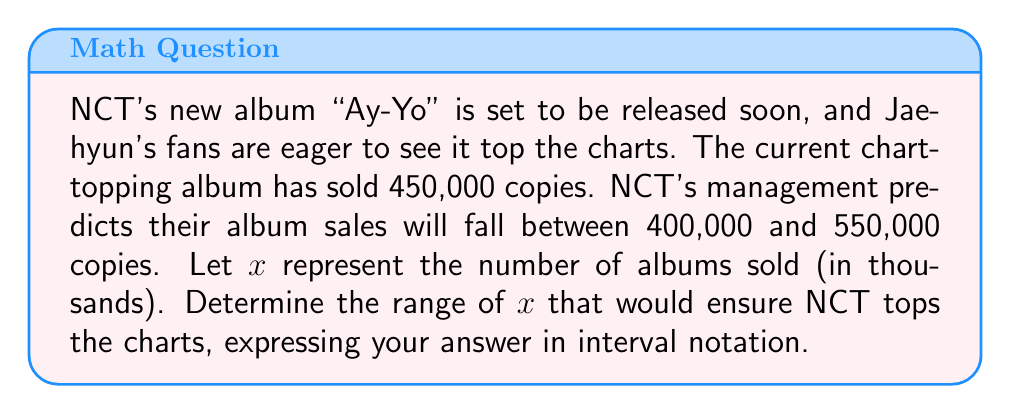What is the answer to this math problem? To solve this problem, we need to consider the given information and set up an appropriate inequality:

1. The current chart-topping album has sold 450,000 copies.
2. NCT's album sales are predicted to be between 400,000 and 550,000 copies.
3. We're using $x$ to represent the number of albums sold in thousands.

For NCT to top the charts, they need to sell more than 450,000 copies. In terms of $x$, this can be expressed as:

$$x > 450$$

Now, we need to combine this with the predicted sales range:

$$400 \leq x \leq 550$$

Combining these inequalities:

$$450 < x \leq 550$$

This inequality represents the range of album sales (in thousands) that would ensure NCT tops the charts while staying within the predicted sales range.

To express this in interval notation, we use parentheses for the strict inequality and square brackets for the inclusive inequality:

$$(450, 550]$$

This interval represents all values of $x$ greater than 450 and less than or equal to 550.
Answer: $(450, 550]$ 